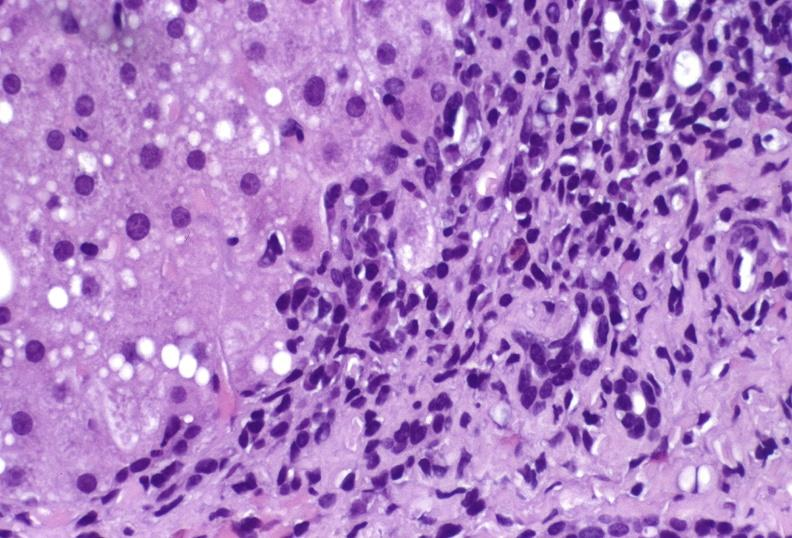does metastatic carcinoma prostate show hepatitis c virus?
Answer the question using a single word or phrase. No 